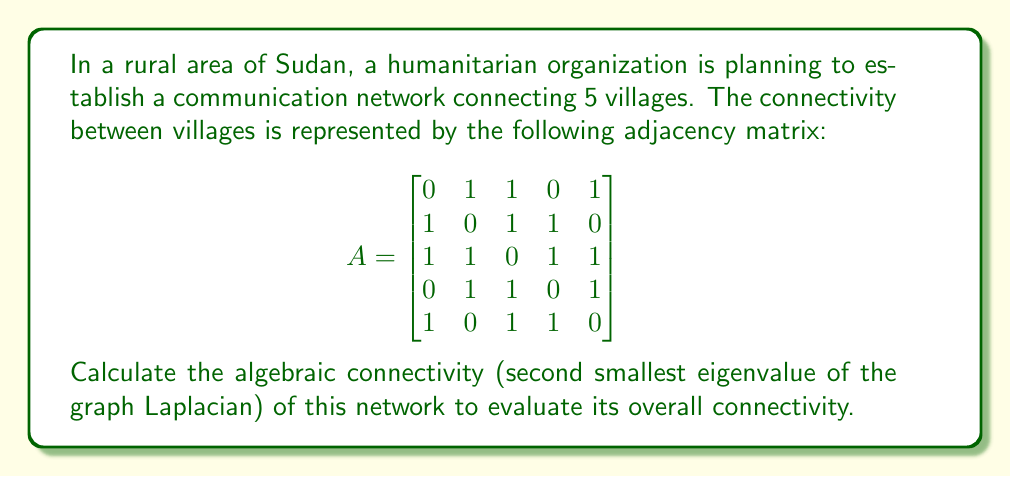Give your solution to this math problem. To solve this problem, we'll follow these steps:

1) First, we need to calculate the degree matrix $D$. The degree of each node is the sum of its connections:
   $$D = \begin{bmatrix}
   3 & 0 & 0 & 0 & 0 \\
   0 & 3 & 0 & 0 & 0 \\
   0 & 0 & 4 & 0 & 0 \\
   0 & 0 & 0 & 3 & 0 \\
   0 & 0 & 0 & 0 & 3
   \end{bmatrix}$$

2) Now, we can calculate the graph Laplacian $L = D - A$:
   $$L = \begin{bmatrix}
   3 & -1 & -1 & 0 & -1 \\
   -1 & 3 & -1 & -1 & 0 \\
   -1 & -1 & 4 & -1 & -1 \\
   0 & -1 & -1 & 3 & -1 \\
   -1 & 0 & -1 & -1 & 3
   \end{bmatrix}$$

3) To find the eigenvalues of $L$, we need to solve the characteristic equation $\det(L - \lambda I) = 0$. This is a complex calculation, so we'll use a computer algebra system to find the eigenvalues.

4) The eigenvalues of $L$ are approximately:
   $\lambda_1 = 0$
   $\lambda_2 = 1.382$
   $\lambda_3 = 3$
   $\lambda_4 = 4$
   $\lambda_5 = 5.618$

5) The algebraic connectivity is the second smallest eigenvalue, which is $\lambda_2 \approx 1.382$.

This value indicates moderate connectivity. In the context of rural Sudan, this suggests that the planned network has a reasonable level of robustness, but there might be room for improvement to enhance communication reliability between villages.
Answer: $1.382$ 